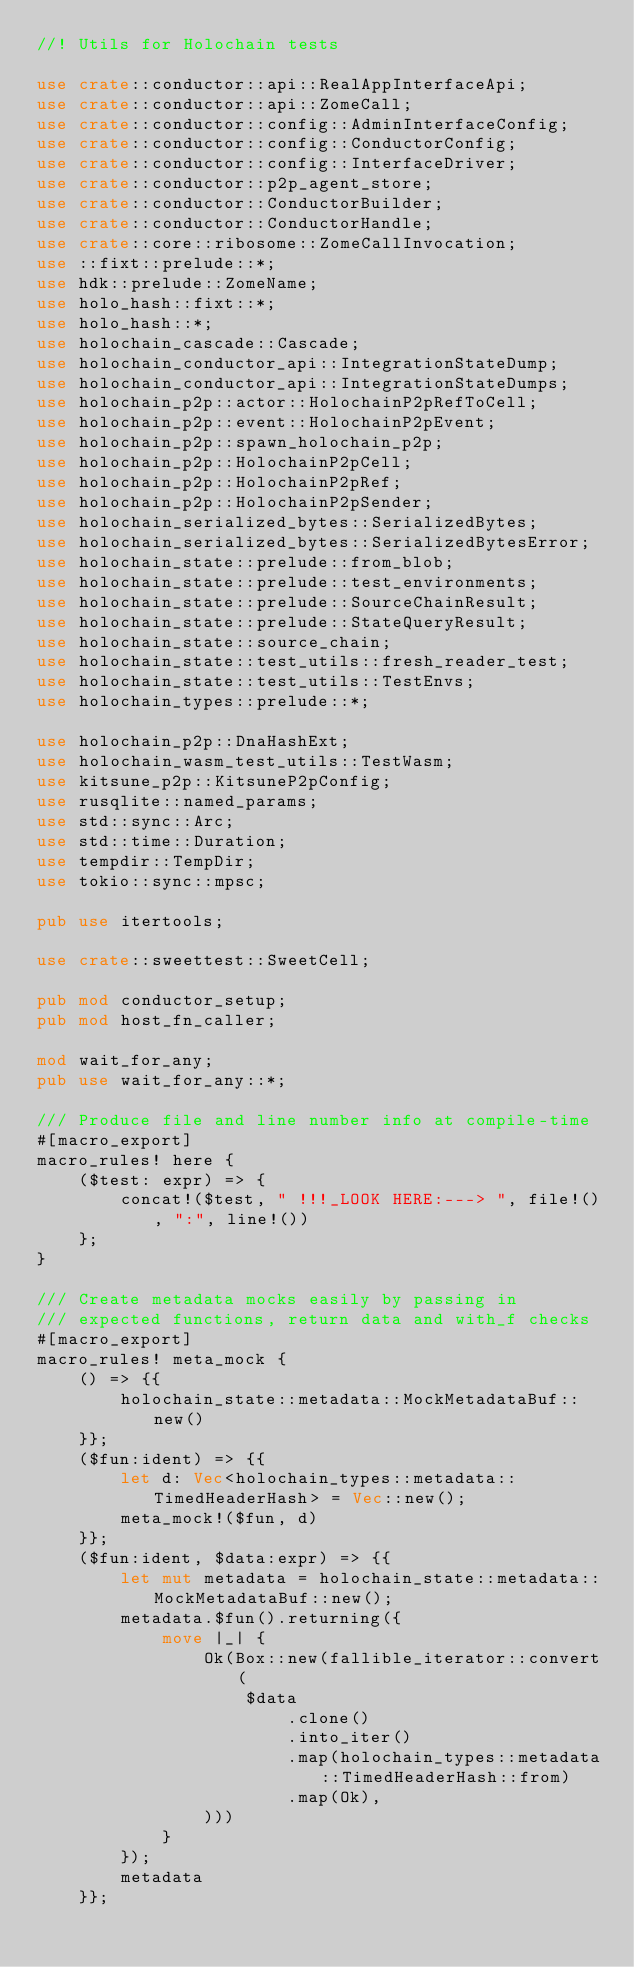<code> <loc_0><loc_0><loc_500><loc_500><_Rust_>//! Utils for Holochain tests

use crate::conductor::api::RealAppInterfaceApi;
use crate::conductor::api::ZomeCall;
use crate::conductor::config::AdminInterfaceConfig;
use crate::conductor::config::ConductorConfig;
use crate::conductor::config::InterfaceDriver;
use crate::conductor::p2p_agent_store;
use crate::conductor::ConductorBuilder;
use crate::conductor::ConductorHandle;
use crate::core::ribosome::ZomeCallInvocation;
use ::fixt::prelude::*;
use hdk::prelude::ZomeName;
use holo_hash::fixt::*;
use holo_hash::*;
use holochain_cascade::Cascade;
use holochain_conductor_api::IntegrationStateDump;
use holochain_conductor_api::IntegrationStateDumps;
use holochain_p2p::actor::HolochainP2pRefToCell;
use holochain_p2p::event::HolochainP2pEvent;
use holochain_p2p::spawn_holochain_p2p;
use holochain_p2p::HolochainP2pCell;
use holochain_p2p::HolochainP2pRef;
use holochain_p2p::HolochainP2pSender;
use holochain_serialized_bytes::SerializedBytes;
use holochain_serialized_bytes::SerializedBytesError;
use holochain_state::prelude::from_blob;
use holochain_state::prelude::test_environments;
use holochain_state::prelude::SourceChainResult;
use holochain_state::prelude::StateQueryResult;
use holochain_state::source_chain;
use holochain_state::test_utils::fresh_reader_test;
use holochain_state::test_utils::TestEnvs;
use holochain_types::prelude::*;

use holochain_p2p::DnaHashExt;
use holochain_wasm_test_utils::TestWasm;
use kitsune_p2p::KitsuneP2pConfig;
use rusqlite::named_params;
use std::sync::Arc;
use std::time::Duration;
use tempdir::TempDir;
use tokio::sync::mpsc;

pub use itertools;

use crate::sweettest::SweetCell;

pub mod conductor_setup;
pub mod host_fn_caller;

mod wait_for_any;
pub use wait_for_any::*;

/// Produce file and line number info at compile-time
#[macro_export]
macro_rules! here {
    ($test: expr) => {
        concat!($test, " !!!_LOOK HERE:---> ", file!(), ":", line!())
    };
}

/// Create metadata mocks easily by passing in
/// expected functions, return data and with_f checks
#[macro_export]
macro_rules! meta_mock {
    () => {{
        holochain_state::metadata::MockMetadataBuf::new()
    }};
    ($fun:ident) => {{
        let d: Vec<holochain_types::metadata::TimedHeaderHash> = Vec::new();
        meta_mock!($fun, d)
    }};
    ($fun:ident, $data:expr) => {{
        let mut metadata = holochain_state::metadata::MockMetadataBuf::new();
        metadata.$fun().returning({
            move |_| {
                Ok(Box::new(fallible_iterator::convert(
                    $data
                        .clone()
                        .into_iter()
                        .map(holochain_types::metadata::TimedHeaderHash::from)
                        .map(Ok),
                )))
            }
        });
        metadata
    }};</code> 